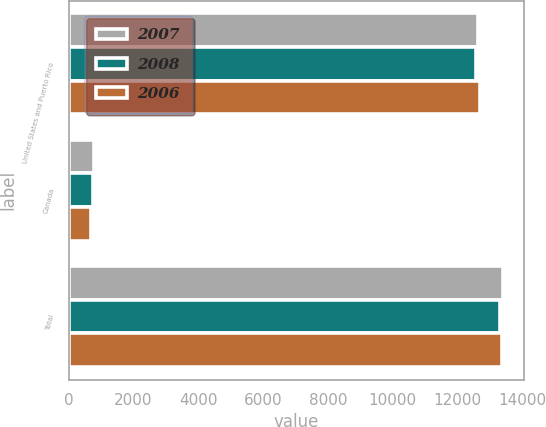<chart> <loc_0><loc_0><loc_500><loc_500><stacked_bar_chart><ecel><fcel>United States and Puerto Rico<fcel>Canada<fcel>Total<nl><fcel>2007<fcel>12621<fcel>767<fcel>13388<nl><fcel>2008<fcel>12566<fcel>744<fcel>13310<nl><fcel>2006<fcel>12674<fcel>689<fcel>13363<nl></chart> 